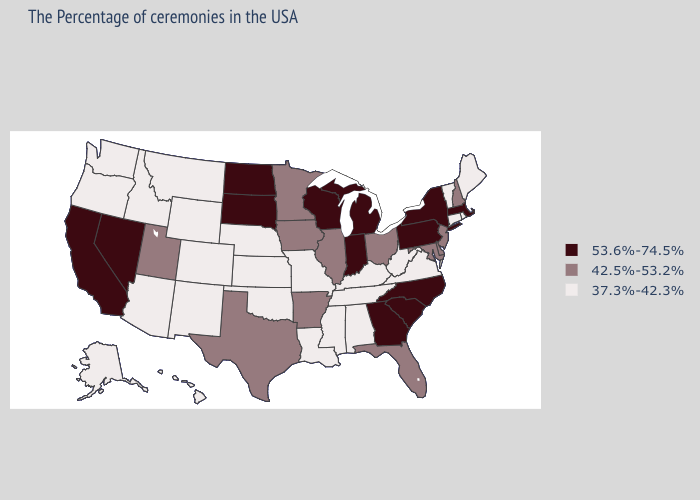Which states have the lowest value in the Northeast?
Answer briefly. Maine, Rhode Island, Vermont, Connecticut. What is the lowest value in the Northeast?
Quick response, please. 37.3%-42.3%. What is the value of Iowa?
Keep it brief. 42.5%-53.2%. What is the value of California?
Quick response, please. 53.6%-74.5%. What is the value of Alaska?
Write a very short answer. 37.3%-42.3%. Name the states that have a value in the range 37.3%-42.3%?
Quick response, please. Maine, Rhode Island, Vermont, Connecticut, Virginia, West Virginia, Kentucky, Alabama, Tennessee, Mississippi, Louisiana, Missouri, Kansas, Nebraska, Oklahoma, Wyoming, Colorado, New Mexico, Montana, Arizona, Idaho, Washington, Oregon, Alaska, Hawaii. What is the value of South Carolina?
Give a very brief answer. 53.6%-74.5%. What is the value of Missouri?
Keep it brief. 37.3%-42.3%. Which states have the lowest value in the MidWest?
Answer briefly. Missouri, Kansas, Nebraska. Name the states that have a value in the range 42.5%-53.2%?
Quick response, please. New Hampshire, New Jersey, Delaware, Maryland, Ohio, Florida, Illinois, Arkansas, Minnesota, Iowa, Texas, Utah. What is the lowest value in the USA?
Write a very short answer. 37.3%-42.3%. What is the value of Louisiana?
Quick response, please. 37.3%-42.3%. Name the states that have a value in the range 42.5%-53.2%?
Be succinct. New Hampshire, New Jersey, Delaware, Maryland, Ohio, Florida, Illinois, Arkansas, Minnesota, Iowa, Texas, Utah. Name the states that have a value in the range 37.3%-42.3%?
Keep it brief. Maine, Rhode Island, Vermont, Connecticut, Virginia, West Virginia, Kentucky, Alabama, Tennessee, Mississippi, Louisiana, Missouri, Kansas, Nebraska, Oklahoma, Wyoming, Colorado, New Mexico, Montana, Arizona, Idaho, Washington, Oregon, Alaska, Hawaii. 